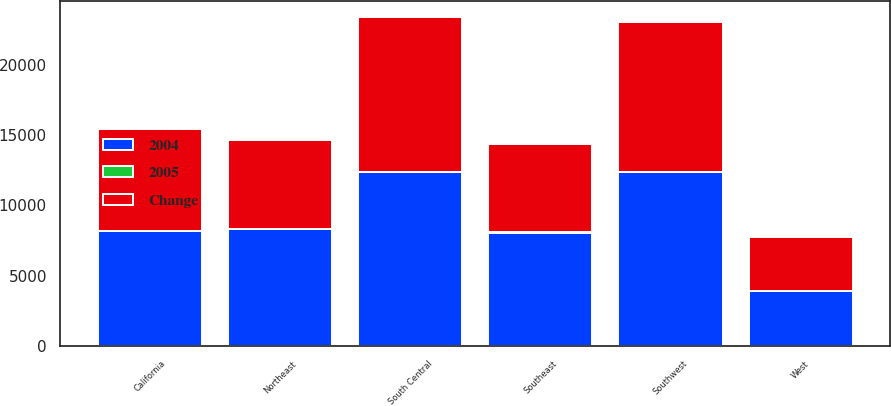<chart> <loc_0><loc_0><loc_500><loc_500><stacked_bar_chart><ecel><fcel>Northeast<fcel>Southeast<fcel>South Central<fcel>Southwest<fcel>California<fcel>West<nl><fcel>2004<fcel>8296<fcel>8050<fcel>12391<fcel>12391<fcel>8171<fcel>3933<nl><fcel>Change<fcel>6300<fcel>6294<fcel>10997<fcel>10632<fcel>7248<fcel>3792<nl><fcel>2005<fcel>32<fcel>28<fcel>13<fcel>17<fcel>13<fcel>4<nl></chart> 